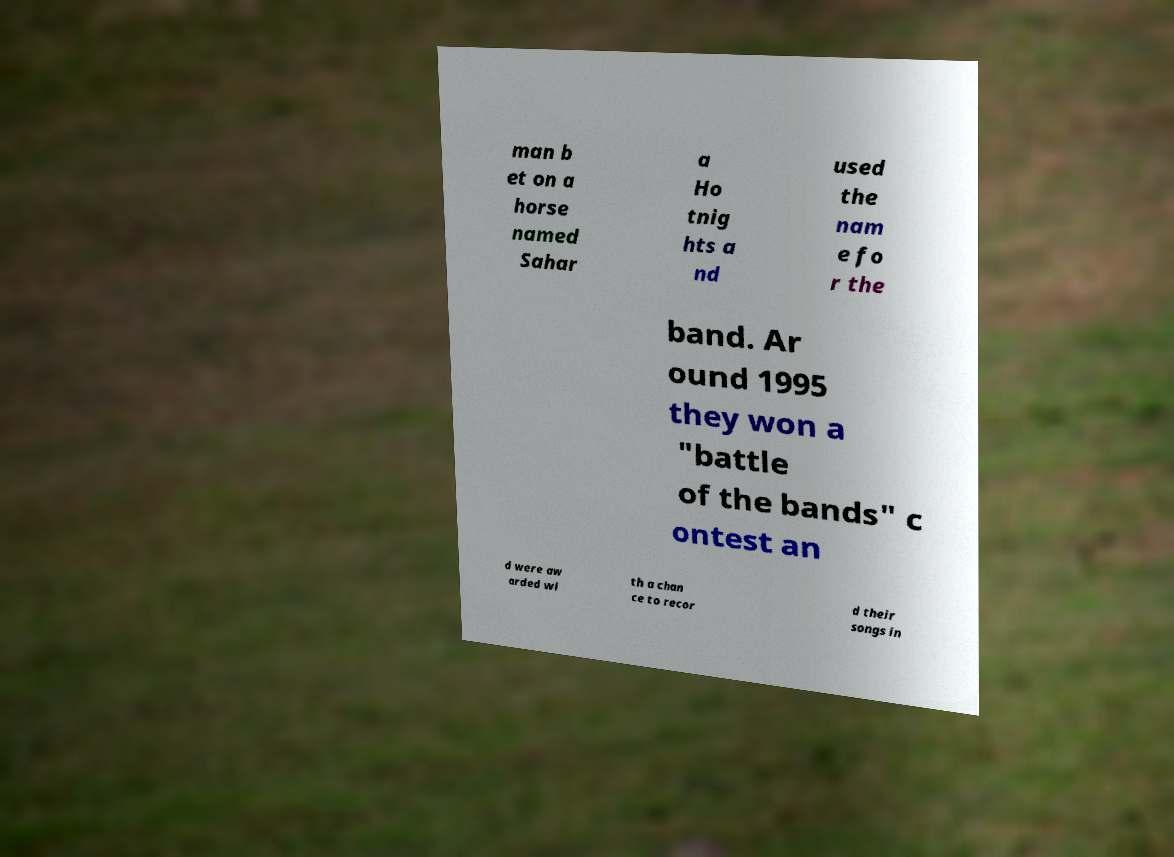Can you accurately transcribe the text from the provided image for me? man b et on a horse named Sahar a Ho tnig hts a nd used the nam e fo r the band. Ar ound 1995 they won a "battle of the bands" c ontest an d were aw arded wi th a chan ce to recor d their songs in 